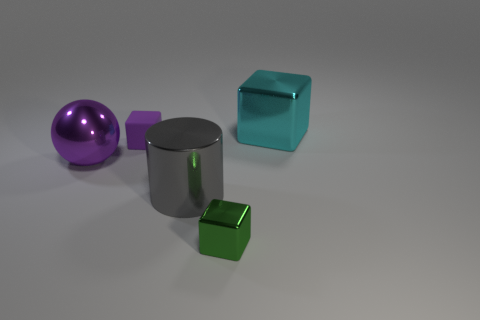Can you describe the shapes and colors of the objects in the image? Certainly! There are a few different shapes presented in the image. To describe a few: there is a purple spherical object, a cylindrical object with a metallic finish, a tiny purple cube, and a larger teal-colored, transparent cube. The colors are distinct, with the metallic surfaces reflecting the environment, causing variations in their appearance. 